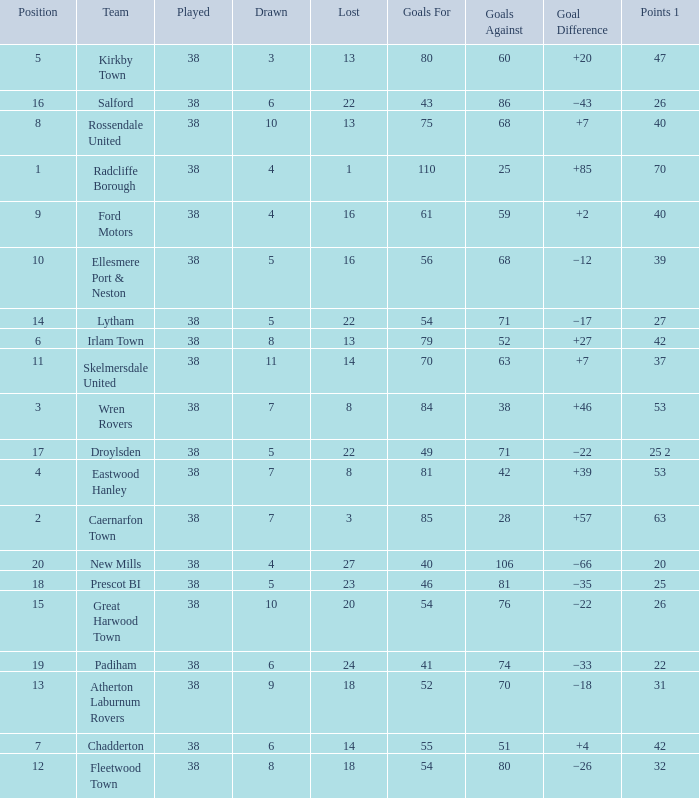How much Drawn has Goals Against larger than 74, and a Lost smaller than 20, and a Played larger than 38? 0.0. 